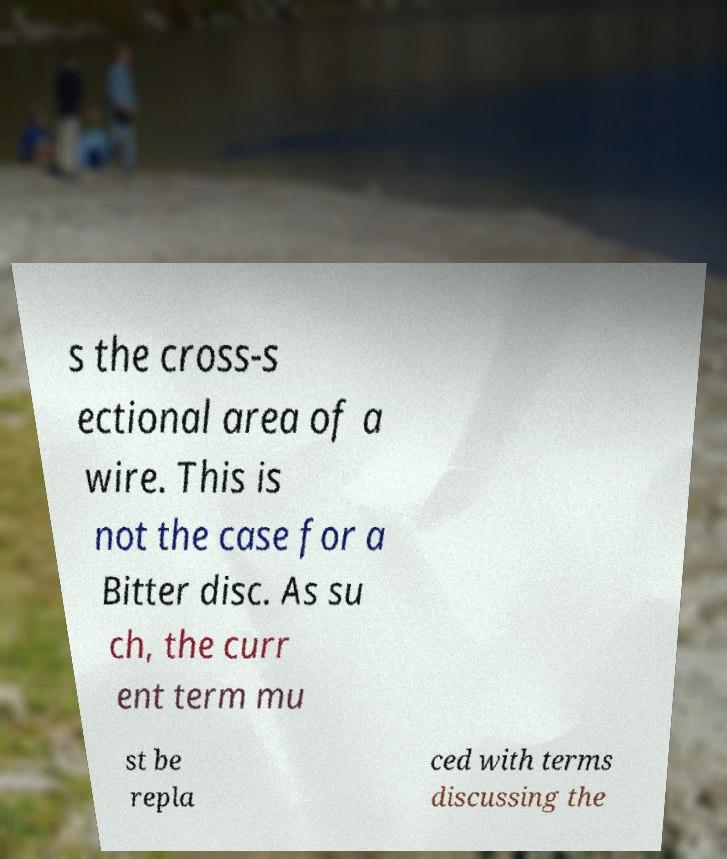There's text embedded in this image that I need extracted. Can you transcribe it verbatim? s the cross-s ectional area of a wire. This is not the case for a Bitter disc. As su ch, the curr ent term mu st be repla ced with terms discussing the 